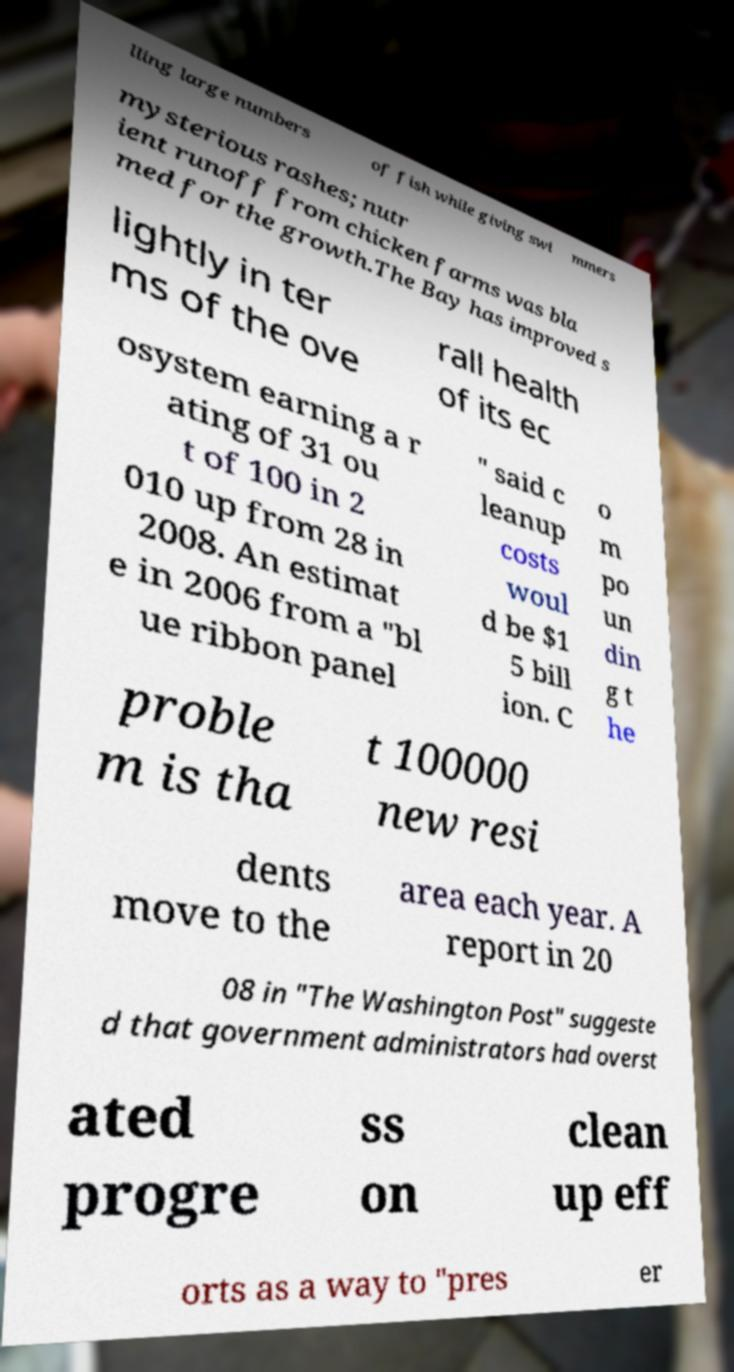Could you assist in decoding the text presented in this image and type it out clearly? lling large numbers of fish while giving swi mmers mysterious rashes; nutr ient runoff from chicken farms was bla med for the growth.The Bay has improved s lightly in ter ms of the ove rall health of its ec osystem earning a r ating of 31 ou t of 100 in 2 010 up from 28 in 2008. An estimat e in 2006 from a "bl ue ribbon panel " said c leanup costs woul d be $1 5 bill ion. C o m po un din g t he proble m is tha t 100000 new resi dents move to the area each year. A report in 20 08 in "The Washington Post" suggeste d that government administrators had overst ated progre ss on clean up eff orts as a way to "pres er 